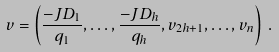Convert formula to latex. <formula><loc_0><loc_0><loc_500><loc_500>v = \left ( \frac { - J D _ { 1 } } { q _ { 1 } } , \dots , \frac { - J D _ { h } } { q _ { h } } , v _ { 2 h + 1 } , \dots , v _ { n } \right ) \, .</formula> 